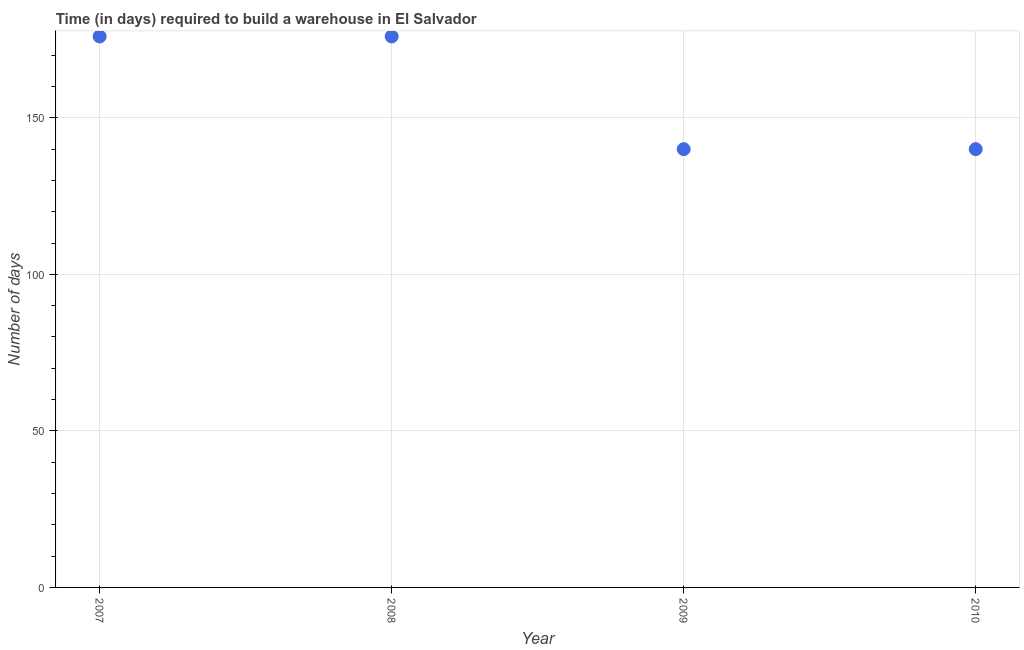What is the time required to build a warehouse in 2007?
Make the answer very short. 176. Across all years, what is the maximum time required to build a warehouse?
Your answer should be compact. 176. Across all years, what is the minimum time required to build a warehouse?
Offer a terse response. 140. In which year was the time required to build a warehouse maximum?
Ensure brevity in your answer.  2007. In which year was the time required to build a warehouse minimum?
Your answer should be very brief. 2009. What is the sum of the time required to build a warehouse?
Your response must be concise. 632. What is the difference between the time required to build a warehouse in 2008 and 2009?
Give a very brief answer. 36. What is the average time required to build a warehouse per year?
Offer a very short reply. 158. What is the median time required to build a warehouse?
Make the answer very short. 158. Do a majority of the years between 2010 and 2008 (inclusive) have time required to build a warehouse greater than 160 days?
Your answer should be compact. No. What is the ratio of the time required to build a warehouse in 2007 to that in 2009?
Keep it short and to the point. 1.26. Is the sum of the time required to build a warehouse in 2007 and 2010 greater than the maximum time required to build a warehouse across all years?
Provide a short and direct response. Yes. What is the difference between the highest and the lowest time required to build a warehouse?
Keep it short and to the point. 36. Does the time required to build a warehouse monotonically increase over the years?
Give a very brief answer. No. How many dotlines are there?
Your answer should be compact. 1. How many years are there in the graph?
Ensure brevity in your answer.  4. What is the difference between two consecutive major ticks on the Y-axis?
Offer a very short reply. 50. Are the values on the major ticks of Y-axis written in scientific E-notation?
Offer a terse response. No. Does the graph contain any zero values?
Keep it short and to the point. No. What is the title of the graph?
Offer a terse response. Time (in days) required to build a warehouse in El Salvador. What is the label or title of the X-axis?
Offer a very short reply. Year. What is the label or title of the Y-axis?
Provide a succinct answer. Number of days. What is the Number of days in 2007?
Ensure brevity in your answer.  176. What is the Number of days in 2008?
Offer a very short reply. 176. What is the Number of days in 2009?
Ensure brevity in your answer.  140. What is the Number of days in 2010?
Make the answer very short. 140. What is the difference between the Number of days in 2007 and 2008?
Your response must be concise. 0. What is the difference between the Number of days in 2007 and 2009?
Keep it short and to the point. 36. What is the difference between the Number of days in 2008 and 2010?
Make the answer very short. 36. What is the ratio of the Number of days in 2007 to that in 2008?
Offer a terse response. 1. What is the ratio of the Number of days in 2007 to that in 2009?
Make the answer very short. 1.26. What is the ratio of the Number of days in 2007 to that in 2010?
Give a very brief answer. 1.26. What is the ratio of the Number of days in 2008 to that in 2009?
Ensure brevity in your answer.  1.26. What is the ratio of the Number of days in 2008 to that in 2010?
Ensure brevity in your answer.  1.26. 